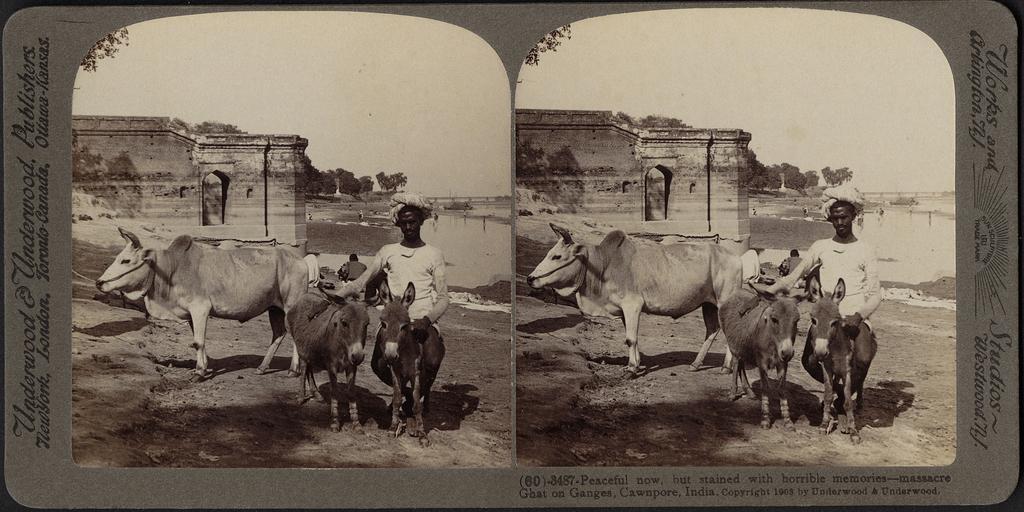Please provide a concise description of this image. In this image there are two photos on the paper, where there are donkeys and a cow, person standing, an ancient building, trees, group of people,sky in the photo , and there is a repeated photo on the other side of the paper, there is a symbol , words and numbers on the paper. 